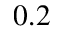Convert formula to latex. <formula><loc_0><loc_0><loc_500><loc_500>0 . 2</formula> 